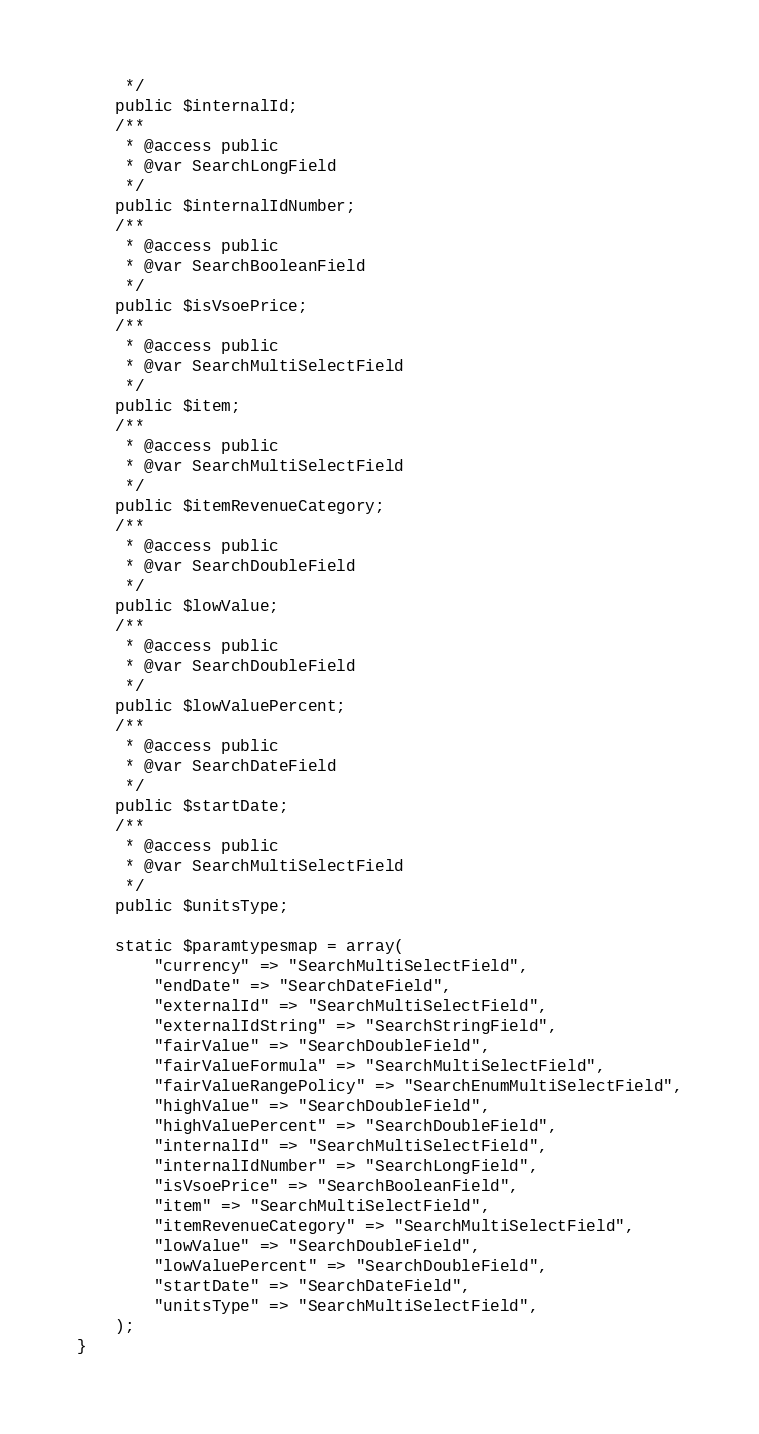<code> <loc_0><loc_0><loc_500><loc_500><_PHP_>	 */
	public $internalId;
	/**
	 * @access public
	 * @var SearchLongField
	 */
	public $internalIdNumber;
	/**
	 * @access public
	 * @var SearchBooleanField
	 */
	public $isVsoePrice;
	/**
	 * @access public
	 * @var SearchMultiSelectField
	 */
	public $item;
	/**
	 * @access public
	 * @var SearchMultiSelectField
	 */
	public $itemRevenueCategory;
	/**
	 * @access public
	 * @var SearchDoubleField
	 */
	public $lowValue;
	/**
	 * @access public
	 * @var SearchDoubleField
	 */
	public $lowValuePercent;
	/**
	 * @access public
	 * @var SearchDateField
	 */
	public $startDate;
	/**
	 * @access public
	 * @var SearchMultiSelectField
	 */
	public $unitsType;

	static $paramtypesmap = array(
		"currency" => "SearchMultiSelectField",
		"endDate" => "SearchDateField",
		"externalId" => "SearchMultiSelectField",
		"externalIdString" => "SearchStringField",
		"fairValue" => "SearchDoubleField",
		"fairValueFormula" => "SearchMultiSelectField",
		"fairValueRangePolicy" => "SearchEnumMultiSelectField",
		"highValue" => "SearchDoubleField",
		"highValuePercent" => "SearchDoubleField",
		"internalId" => "SearchMultiSelectField",
		"internalIdNumber" => "SearchLongField",
		"isVsoePrice" => "SearchBooleanField",
		"item" => "SearchMultiSelectField",
		"itemRevenueCategory" => "SearchMultiSelectField",
		"lowValue" => "SearchDoubleField",
		"lowValuePercent" => "SearchDoubleField",
		"startDate" => "SearchDateField",
		"unitsType" => "SearchMultiSelectField",
	);
}
</code> 